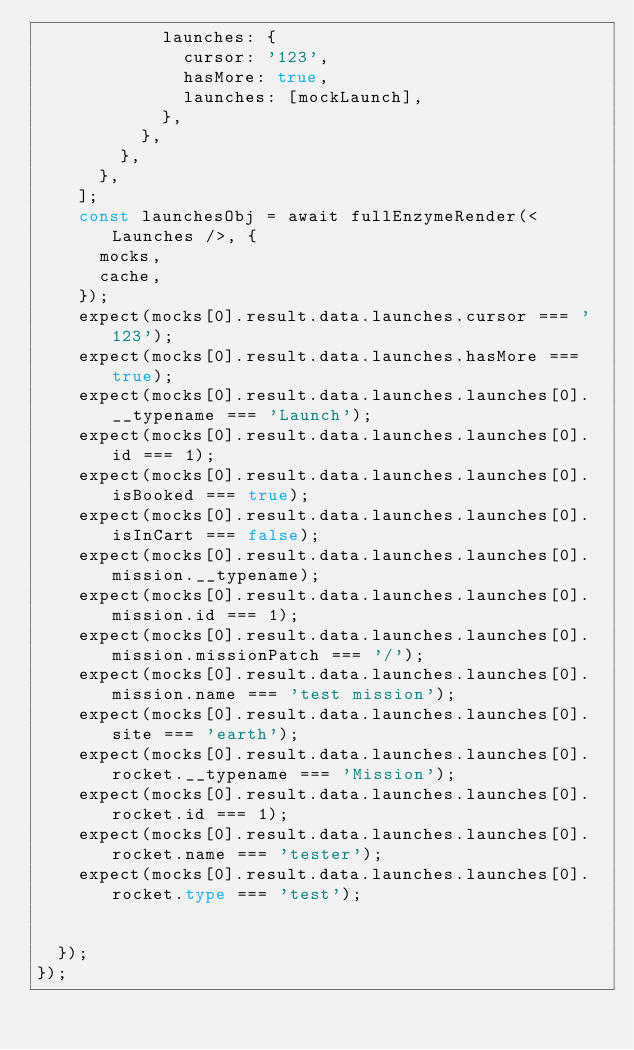<code> <loc_0><loc_0><loc_500><loc_500><_TypeScript_>            launches: {
              cursor: '123',
              hasMore: true,
              launches: [mockLaunch],
            },
          },
        },
      },
    ];
    const launchesObj = await fullEnzymeRender(<Launches />, {
      mocks,
      cache,
    });
    expect(mocks[0].result.data.launches.cursor === '123');
    expect(mocks[0].result.data.launches.hasMore === true);
    expect(mocks[0].result.data.launches.launches[0].__typename === 'Launch');
    expect(mocks[0].result.data.launches.launches[0].id === 1);
    expect(mocks[0].result.data.launches.launches[0].isBooked === true);
    expect(mocks[0].result.data.launches.launches[0].isInCart === false);
    expect(mocks[0].result.data.launches.launches[0].mission.__typename);
    expect(mocks[0].result.data.launches.launches[0].mission.id === 1);
    expect(mocks[0].result.data.launches.launches[0].mission.missionPatch === '/');
    expect(mocks[0].result.data.launches.launches[0].mission.name === 'test mission');
    expect(mocks[0].result.data.launches.launches[0].site === 'earth');
    expect(mocks[0].result.data.launches.launches[0].rocket.__typename === 'Mission');
    expect(mocks[0].result.data.launches.launches[0].rocket.id === 1);
    expect(mocks[0].result.data.launches.launches[0].rocket.name === 'tester');
    expect(mocks[0].result.data.launches.launches[0].rocket.type === 'test');


  });
});
</code> 